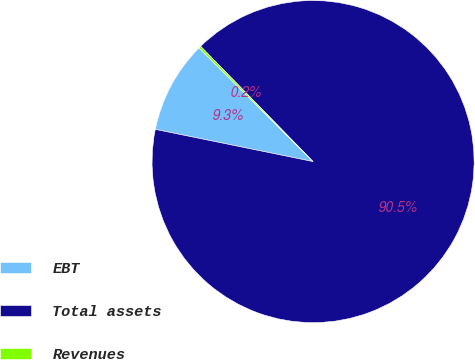Convert chart to OTSL. <chart><loc_0><loc_0><loc_500><loc_500><pie_chart><fcel>EBT<fcel>Total assets<fcel>Revenues<nl><fcel>9.26%<fcel>90.52%<fcel>0.23%<nl></chart> 